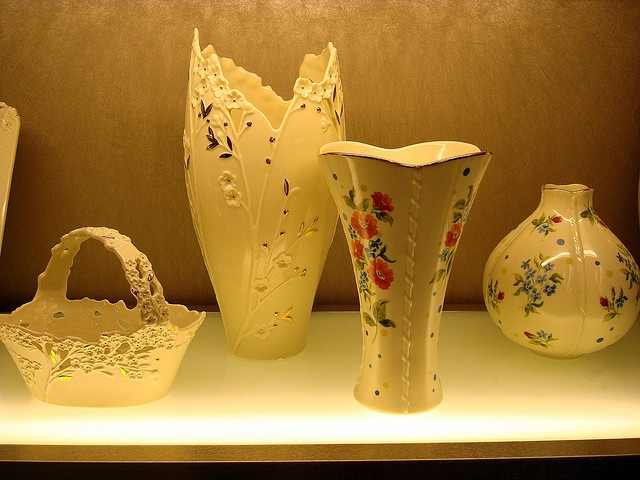Describe the objects in this image and their specific colors. I can see vase in brown, orange, and gold tones, vase in brown, olive, and orange tones, vase in brown, gold, olive, and orange tones, and vase in brown, orange, and olive tones in this image. 